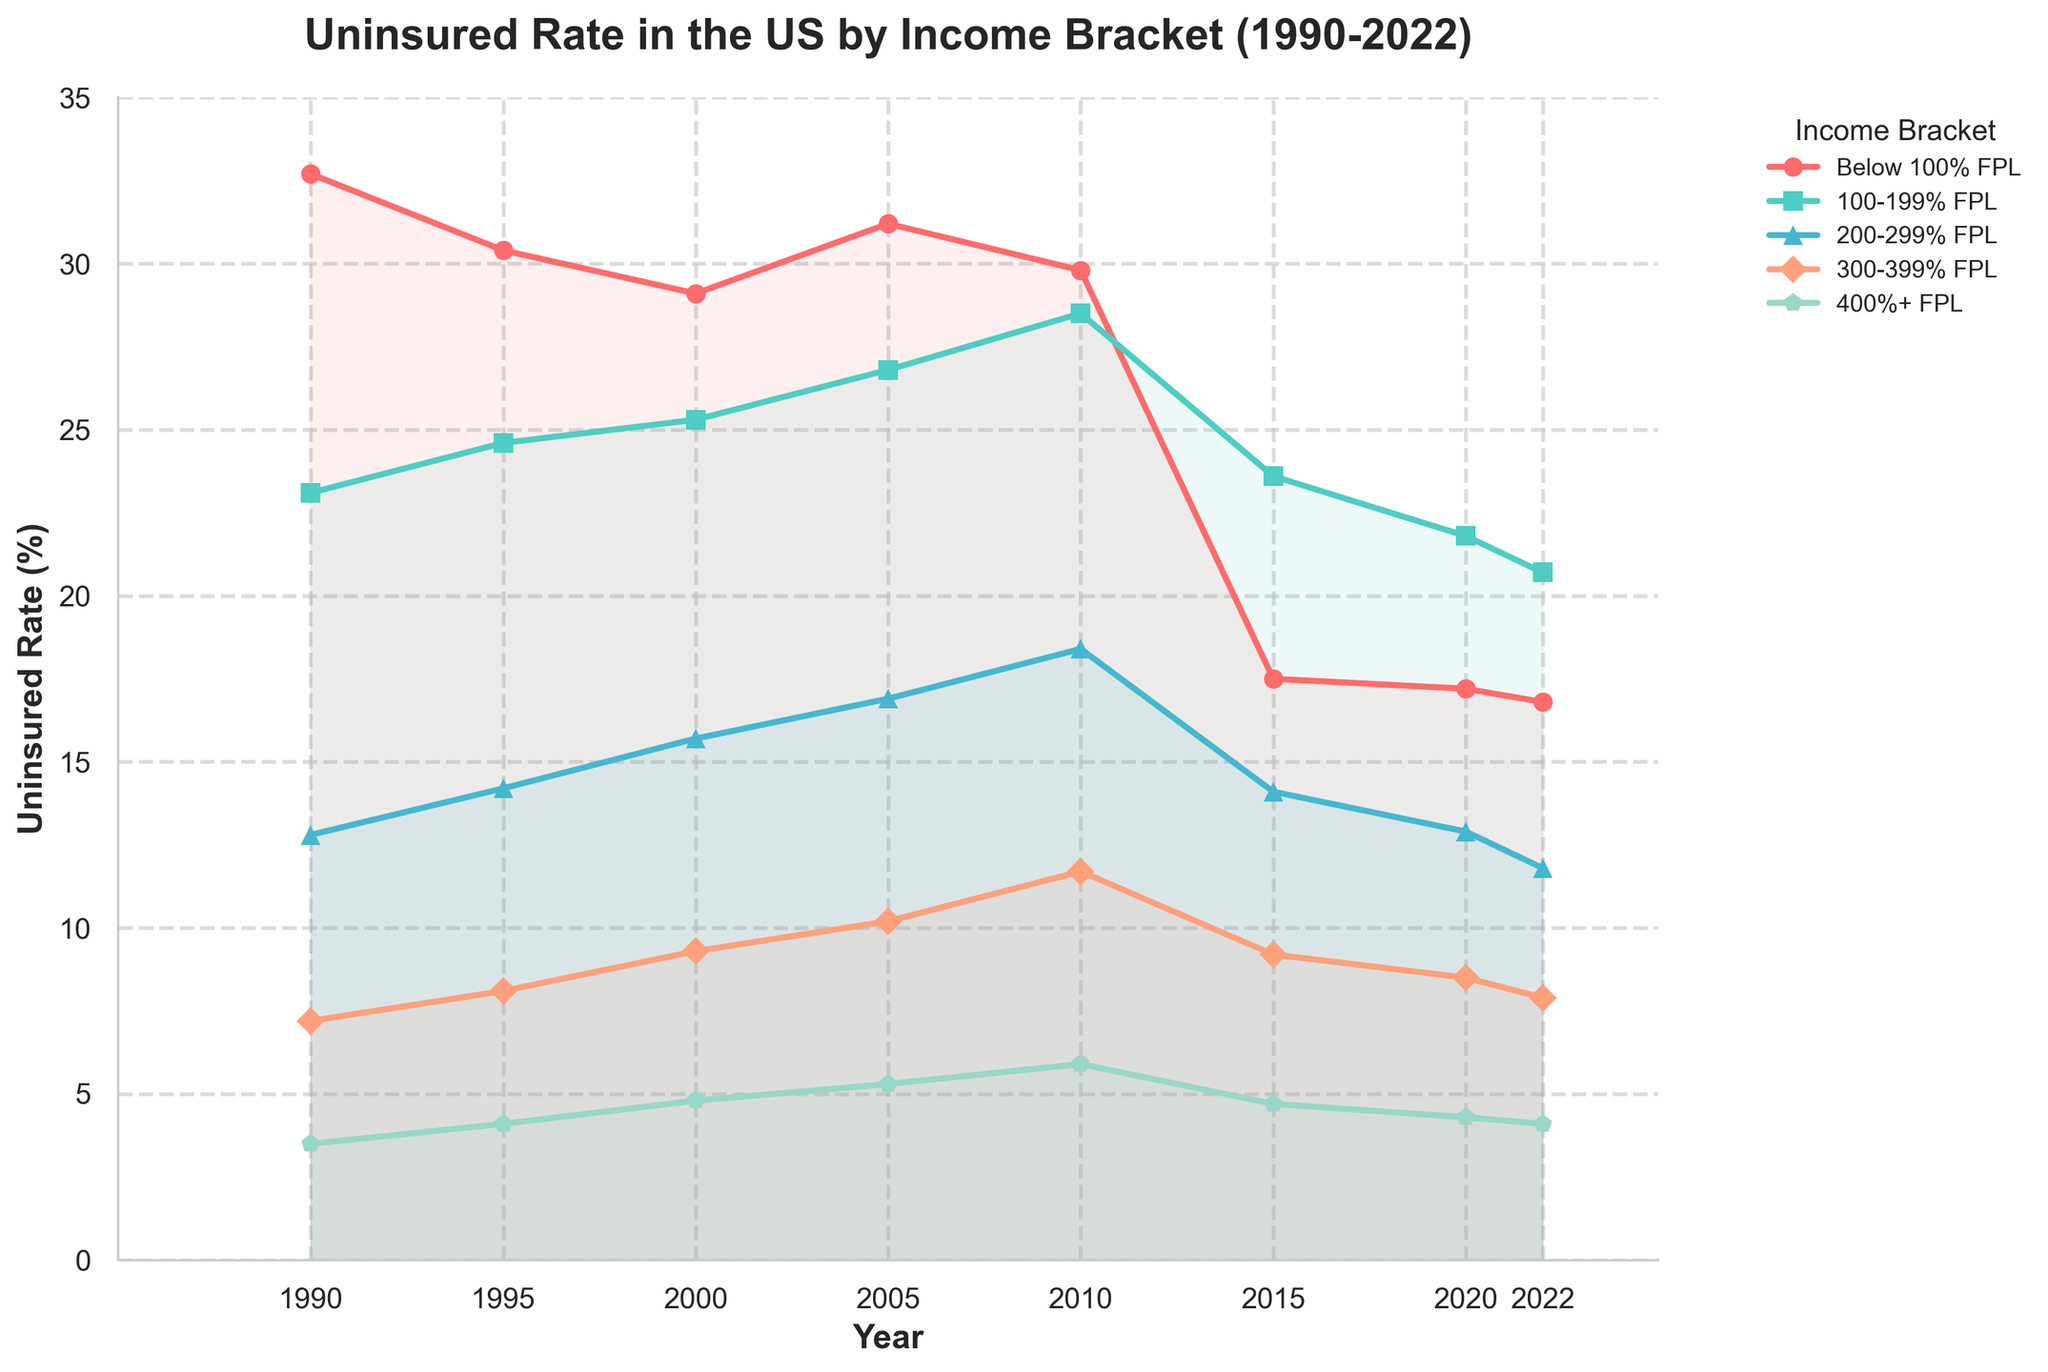Which income bracket has consistently had the highest uninsured rate from 1990 to 2022? The line representing the "Below 100% FPL" income bracket is always the highest across all years.
Answer: Below 100% FPL How did the uninsured rate for the 200-299% FPL bracket change from 1990 to 2022? The uninsured rate for this bracket started at 12.8% in 1990 and decreased to 11.8% in 2022. It shows a small reduction over the period.
Answer: Decreased slightly What is the difference in uninsured rate between the 100-199% FPL and 300-399% FPL brackets in 2010? In 2010, the uninsured rate for 100-199% FPL was 28.5%, and for 300-399% FPL, it was 11.7%. The difference is 28.5% - 11.7%.
Answer: 16.8% Which income bracket shows the most significant decrease in uninsured rate from 2010 to 2015? "Below 100% FPL" decreased from 29.8% in 2010 to 17.5% in 2015, which is a notable drop of 12.3%.
Answer: Below 100% FPL What is the average uninsured rate for the 400%+ FPL bracket across all the years shown? The uninsured rates are 3.5, 4.1, 4.8, 5.3, 5.9, 4.7, 4.3, and 4.1. Their sum is 36.7, so the average is 36.7/8.
Answer: 4.6% In what year did the 100-199% FPL bracket reach its peak uninsured rate, and what was the rate? The 100-199% FPL bracket peaked in 2010 with an uninsured rate of 28.5%.
Answer: 2010, 28.5% Compare the uninsured rate change for the Below 100% FPL and 400%+ FPL brackets from 1990 to 2022. Which had a greater absolute change? The "Below 100% FPL" changed from 32.7% to 16.8% (difference of 15.9%), and the "400%+ FPL" changed from 3.5% to 4.1% (difference of 0.6%). The Below 100% FPL bracket had a greater change.
Answer: Below 100% FPL Which income bracket has the least variation in uninsured rates across all years? The "400%+ FPL" bracket has the least variation, with rates varying only between 3.5% and 5.9%.
Answer: 400%+ FPL What was the general trend in uninsured rates for the 300-399% FPL bracket from 1990 to 2010, and what happened after 2010? The rate generally increased from 7.2% in 1990 to 11.7% in 2010, and then it decreased to 7.9% by 2022.
Answer: Increase, then decrease How much did the uninsured rate for the Below 100% FPL bracket decrease from its peak year to 2022? The peak was in 1990 at 32.7%, and by 2022 it was 16.8%. The difference is 32.7% - 16.8%.
Answer: 15.9% 